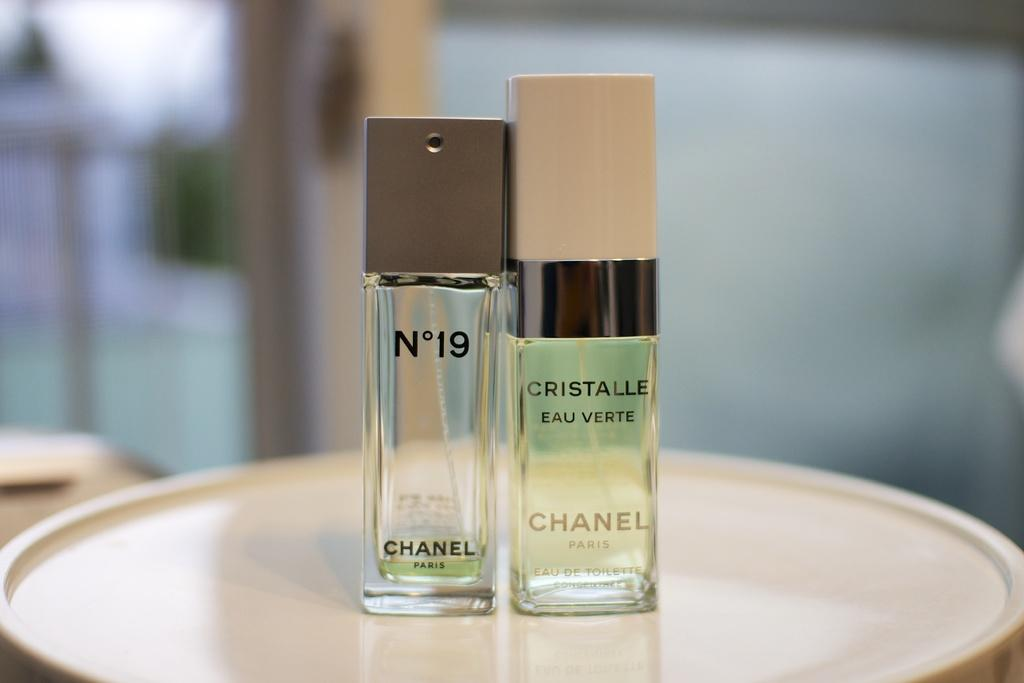<image>
Summarize the visual content of the image. Two perfume bottles from N'19 and Cristalle Eau Verte 